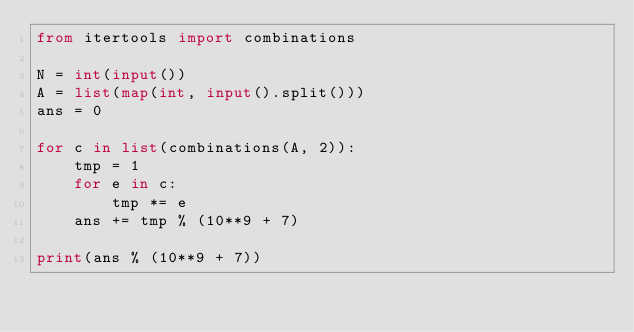Convert code to text. <code><loc_0><loc_0><loc_500><loc_500><_Python_>from itertools import combinations

N = int(input())
A = list(map(int, input().split()))
ans = 0

for c in list(combinations(A, 2)):
    tmp = 1
    for e in c:
        tmp *= e
    ans += tmp % (10**9 + 7)

print(ans % (10**9 + 7))</code> 